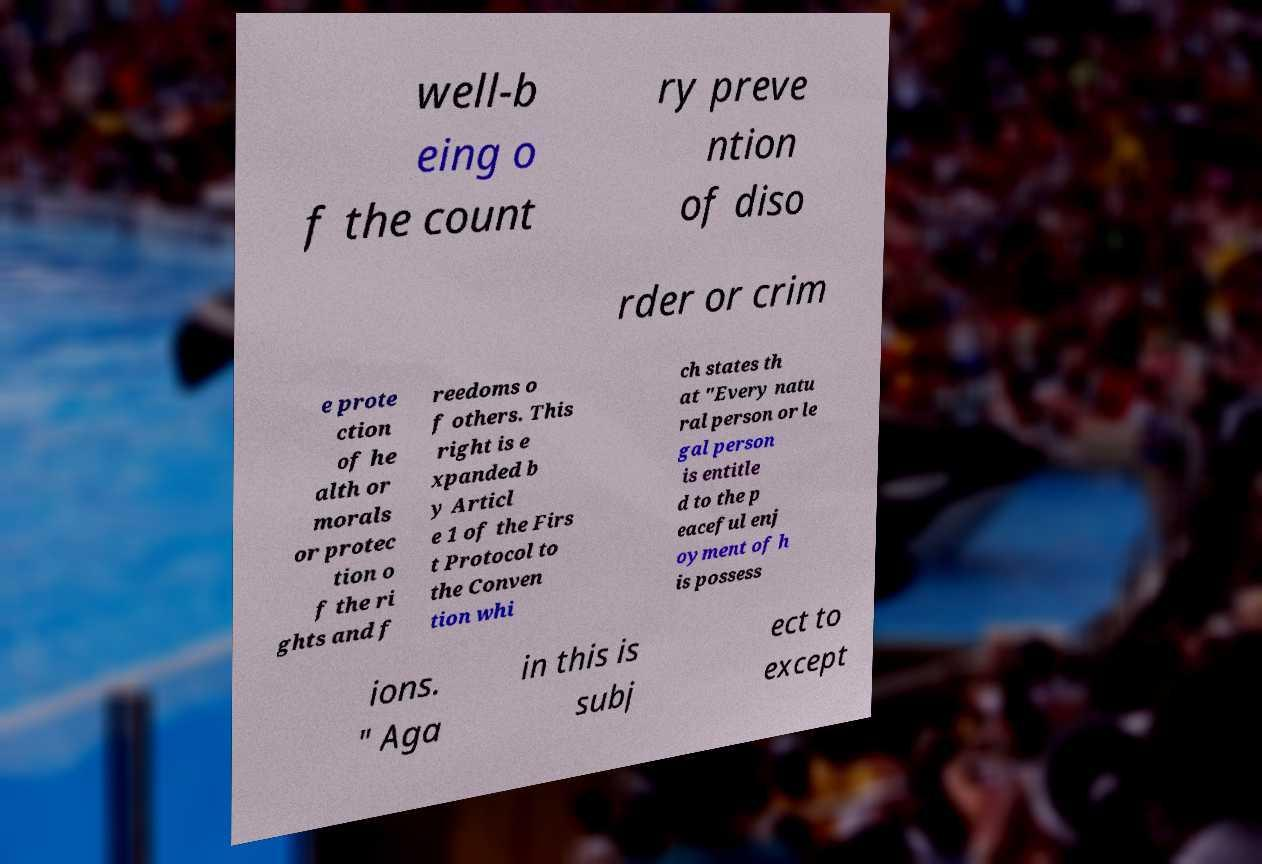There's text embedded in this image that I need extracted. Can you transcribe it verbatim? well-b eing o f the count ry preve ntion of diso rder or crim e prote ction of he alth or morals or protec tion o f the ri ghts and f reedoms o f others. This right is e xpanded b y Articl e 1 of the Firs t Protocol to the Conven tion whi ch states th at "Every natu ral person or le gal person is entitle d to the p eaceful enj oyment of h is possess ions. " Aga in this is subj ect to except 